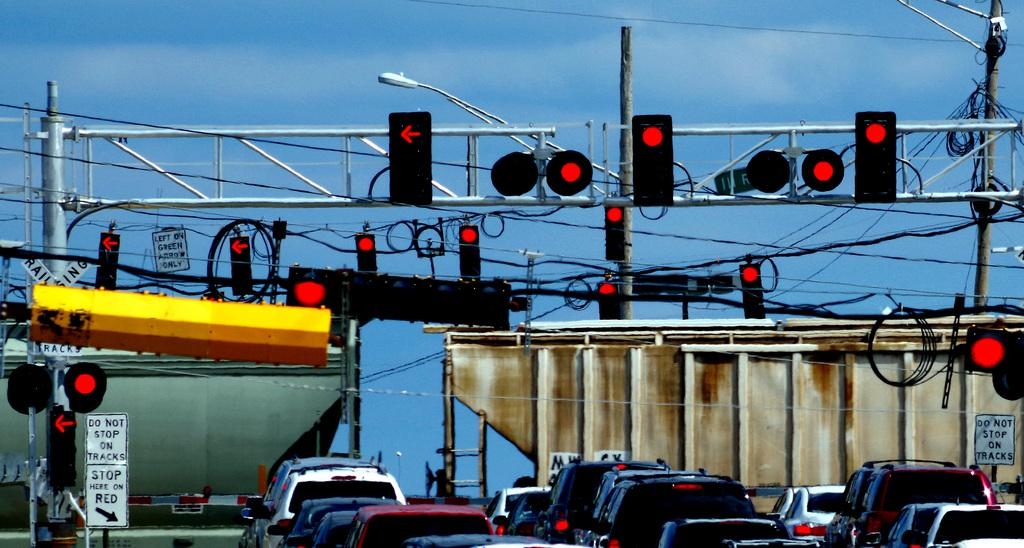What type of structures are present in the image? There are signal poles, an electric pole, and a light pole in the image. What else can be seen in the image besides these structures? There are many vehicles and a board visible in the image. What is the color of the sky in the image? The sky is blue in the image. Are there any electric wires in the image? Yes, there are electric wires in the image. Can you see any children playing near the ocean in the image? There is no ocean or children present in the image. What type of flag is flying on the light pole in the image? There is no flag visible on the light pole in the image. 